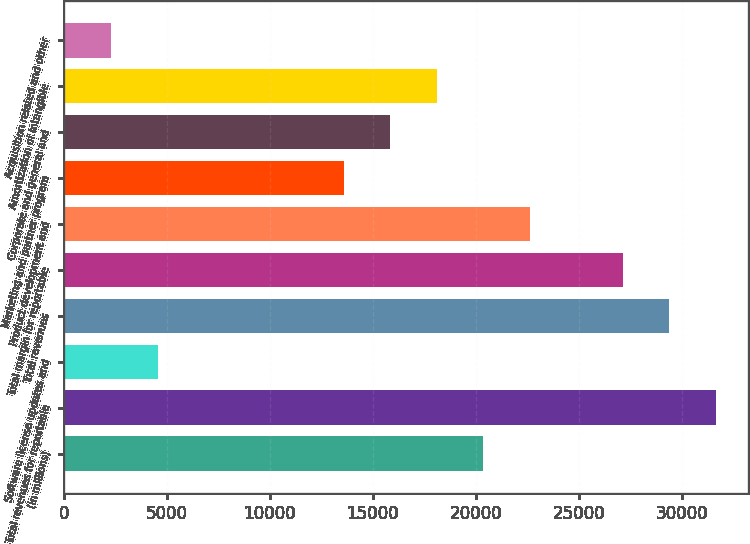<chart> <loc_0><loc_0><loc_500><loc_500><bar_chart><fcel>(in millions)<fcel>Total revenues for reportable<fcel>Software license updates and<fcel>Total revenues<fcel>Total margin for reportable<fcel>Product development and<fcel>Marketing and partner program<fcel>Corporate and general and<fcel>Amortization of intangible<fcel>Acquisition related and other<nl><fcel>20352.2<fcel>31636.2<fcel>4554.6<fcel>29379.4<fcel>27122.6<fcel>22609<fcel>13581.8<fcel>15838.6<fcel>18095.4<fcel>2297.8<nl></chart> 